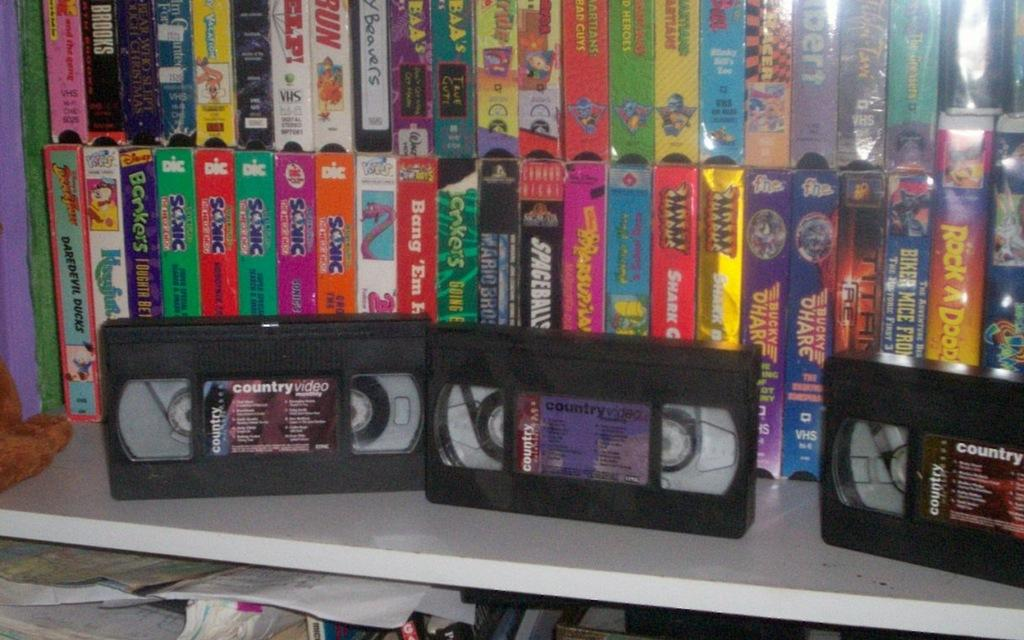<image>
Offer a succinct explanation of the picture presented. Many VHS tapes including country music videos and old movies like Spaceballs. 